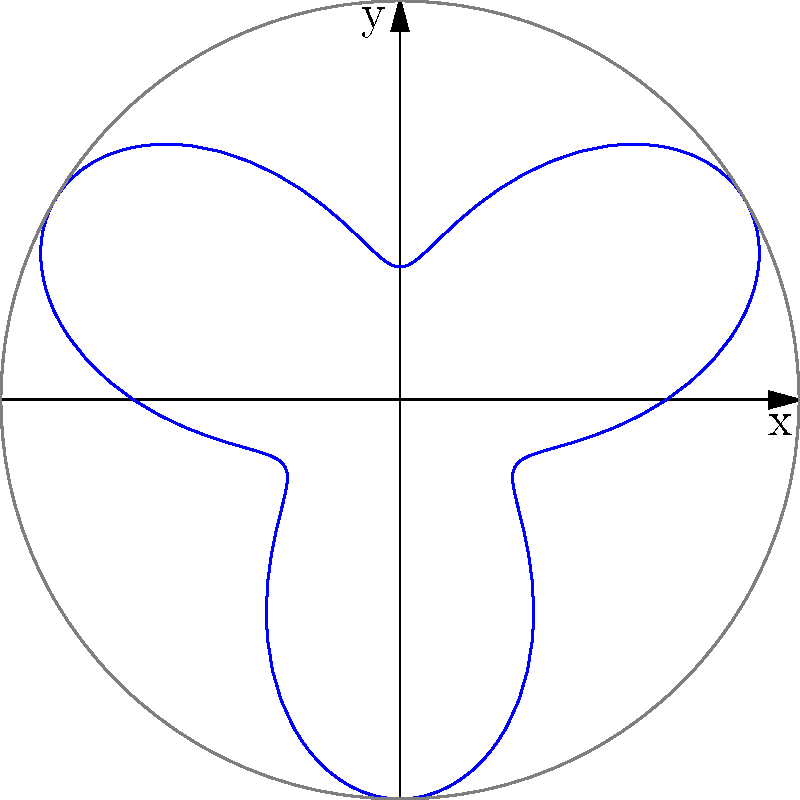The cross-sectional area of a rocket nozzle can be approximated by the polar equation $r = 2 + \sin(3\theta)$, where $r$ is in centimeters. Calculate the maximum cross-sectional area of the nozzle in square centimeters. To find the maximum cross-sectional area, we need to follow these steps:

1) The maximum radius occurs when $\sin(3\theta) = 1$, which gives $r_{max} = 3$ cm.

2) The minimum radius occurs when $\sin(3\theta) = -1$, which gives $r_{min} = 1$ cm.

3) The cross-sectional area of the nozzle can be approximated as a circle with radius equal to the average of $r_{max}$ and $r_{min}$:

   $r_{avg} = \frac{r_{max} + r_{min}}{2} = \frac{3 + 1}{2} = 2$ cm

4) The area of a circle is given by $A = \pi r^2$. Therefore, the maximum cross-sectional area is:

   $A = \pi (2\text{ cm})^2 = 4\pi \text{ cm}^2$

5) Calculating this value:

   $A = 4 \cdot 3.14159... \approx 12.57 \text{ cm}^2$
Answer: $12.57 \text{ cm}^2$ 